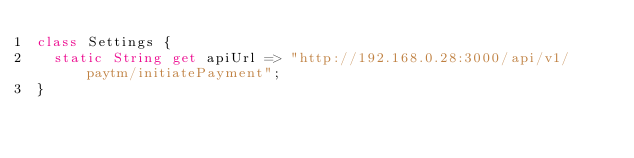Convert code to text. <code><loc_0><loc_0><loc_500><loc_500><_Dart_>class Settings {
  static String get apiUrl => "http://192.168.0.28:3000/api/v1/paytm/initiatePayment";
}</code> 